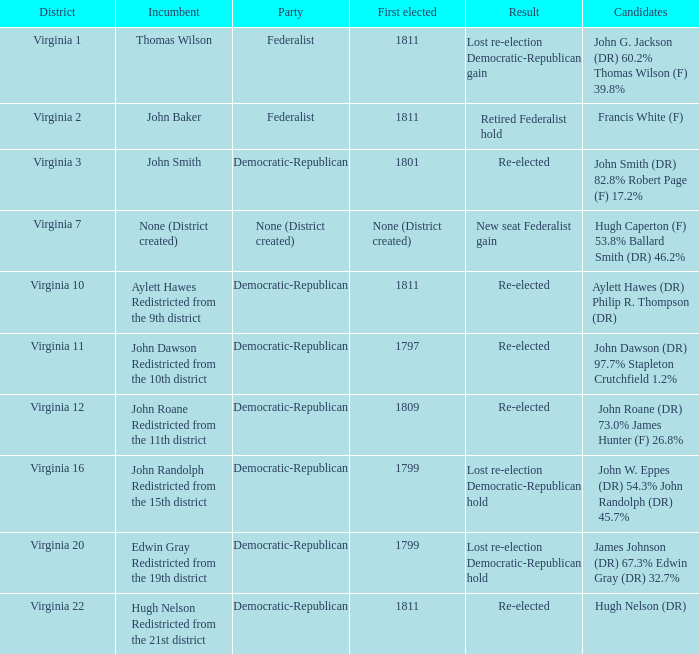What is the district associated with thomas wilson? Virginia 1. 